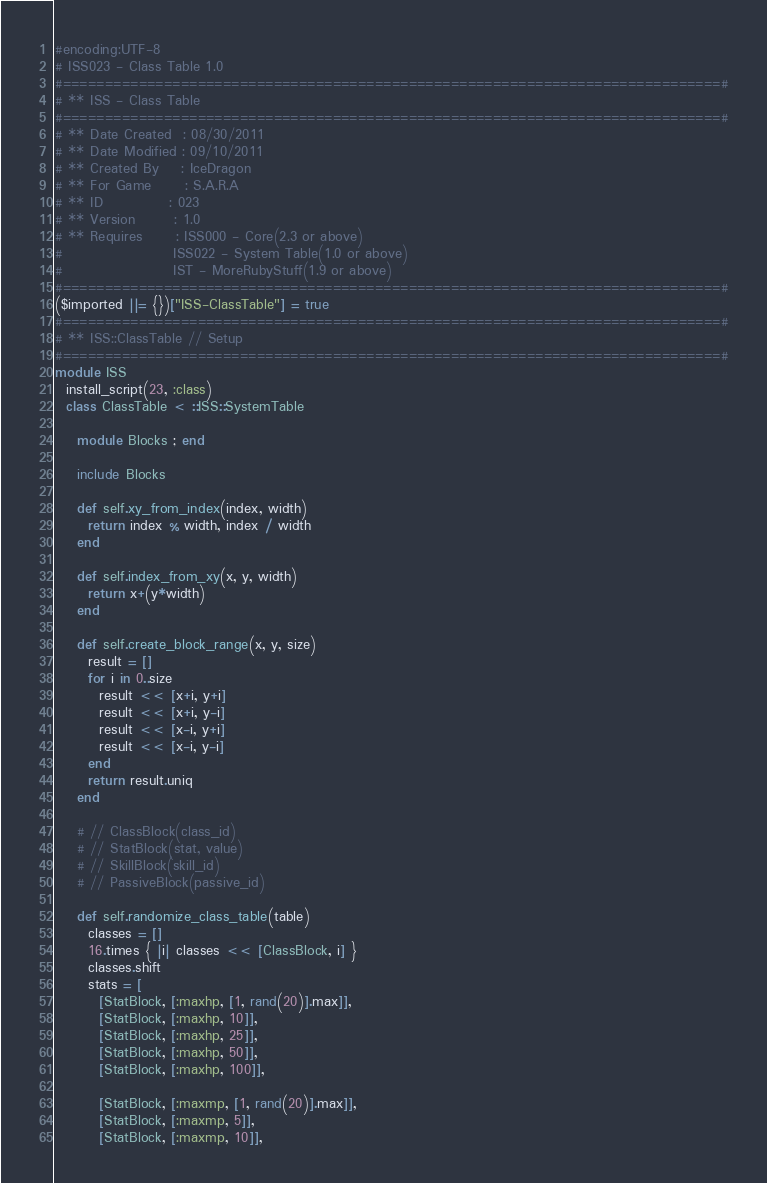Convert code to text. <code><loc_0><loc_0><loc_500><loc_500><_Ruby_>#encoding:UTF-8
# ISS023 - Class Table 1.0
#==============================================================================#
# ** ISS - Class Table
#==============================================================================#
# ** Date Created  : 08/30/2011
# ** Date Modified : 09/10/2011
# ** Created By    : IceDragon
# ** For Game      : S.A.R.A
# ** ID            : 023
# ** Version       : 1.0
# ** Requires      : ISS000 - Core(2.3 or above)
#                    ISS022 - System Table(1.0 or above)
#                    IST - MoreRubyStuff(1.9 or above)
#==============================================================================#
($imported ||= {})["ISS-ClassTable"] = true
#==============================================================================#
# ** ISS::ClassTable // Setup
#==============================================================================#
module ISS
  install_script(23, :class)
  class ClassTable < ::ISS::SystemTable

    module Blocks ; end

    include Blocks

    def self.xy_from_index(index, width)
      return index % width, index / width
    end

    def self.index_from_xy(x, y, width)
      return x+(y*width)
    end

    def self.create_block_range(x, y, size)
      result = []
      for i in 0..size
        result << [x+i, y+i]
        result << [x+i, y-i]
        result << [x-i, y+i]
        result << [x-i, y-i]
      end
      return result.uniq
    end

    # // ClassBlock(class_id)
    # // StatBlock(stat, value)
    # // SkillBlock(skill_id)
    # // PassiveBlock(passive_id)

    def self.randomize_class_table(table)
      classes = []
      16.times { |i| classes << [ClassBlock, i] }
      classes.shift
      stats = [
        [StatBlock, [:maxhp, [1, rand(20)].max]],
        [StatBlock, [:maxhp, 10]],
        [StatBlock, [:maxhp, 25]],
        [StatBlock, [:maxhp, 50]],
        [StatBlock, [:maxhp, 100]],

        [StatBlock, [:maxmp, [1, rand(20)].max]],
        [StatBlock, [:maxmp, 5]],
        [StatBlock, [:maxmp, 10]],</code> 